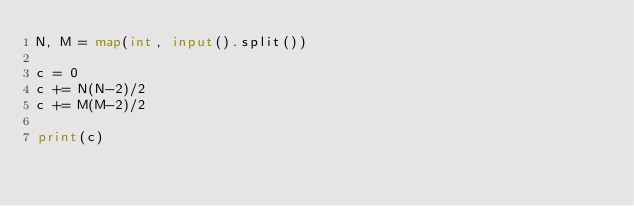Convert code to text. <code><loc_0><loc_0><loc_500><loc_500><_Python_>N, M = map(int, input().split())

c = 0
c += N(N-2)/2
c += M(M-2)/2

print(c)

</code> 